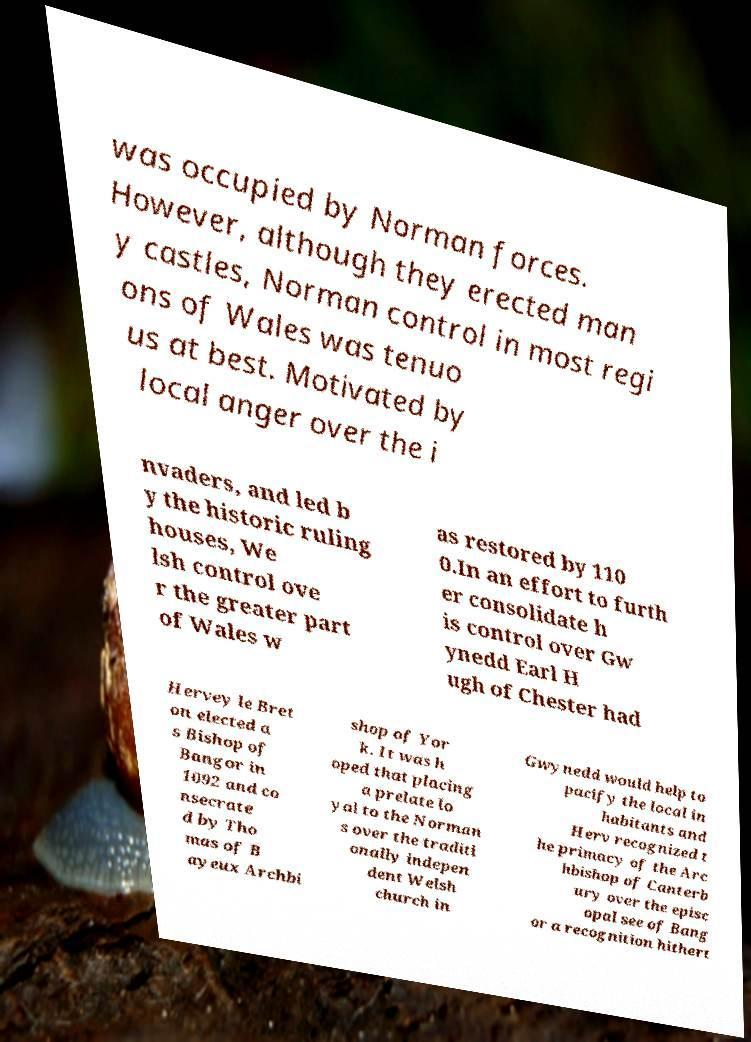I need the written content from this picture converted into text. Can you do that? was occupied by Norman forces. However, although they erected man y castles, Norman control in most regi ons of Wales was tenuo us at best. Motivated by local anger over the i nvaders, and led b y the historic ruling houses, We lsh control ove r the greater part of Wales w as restored by 110 0.In an effort to furth er consolidate h is control over Gw ynedd Earl H ugh of Chester had Hervey le Bret on elected a s Bishop of Bangor in 1092 and co nsecrate d by Tho mas of B ayeux Archbi shop of Yor k. It was h oped that placing a prelate lo yal to the Norman s over the traditi onally indepen dent Welsh church in Gwynedd would help to pacify the local in habitants and Herv recognized t he primacy of the Arc hbishop of Canterb ury over the episc opal see of Bang or a recognition hithert 